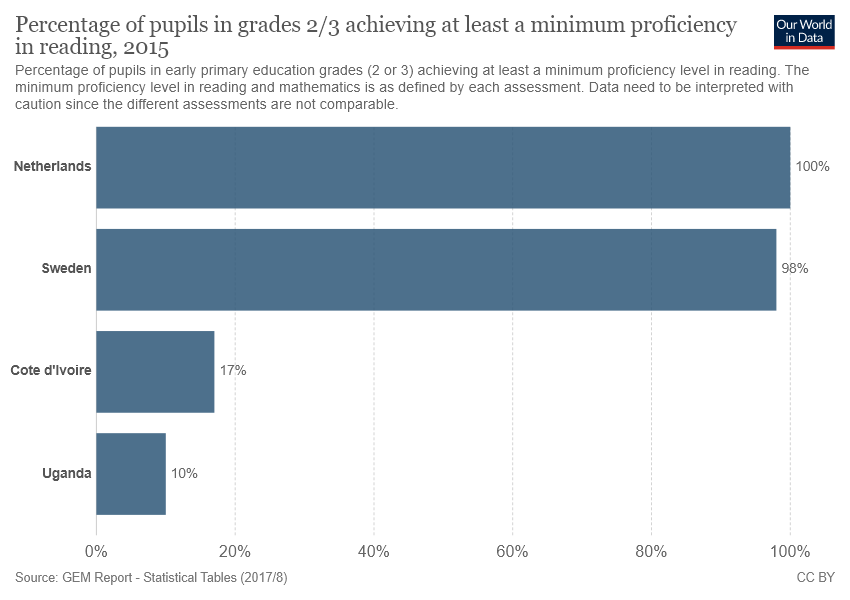Identify some key points in this picture. In 2015, a minimum of 95% of pupils in grades 2/3 in countries achieved proficiency in reading. How many countries have this percentage of pupils who achieved proficiency in reading? According to data from 2015, Uganda has the lowest percentage of students in Grades 2/3 who achieved at least a minimum proficiency in reading among all countries surveyed. 